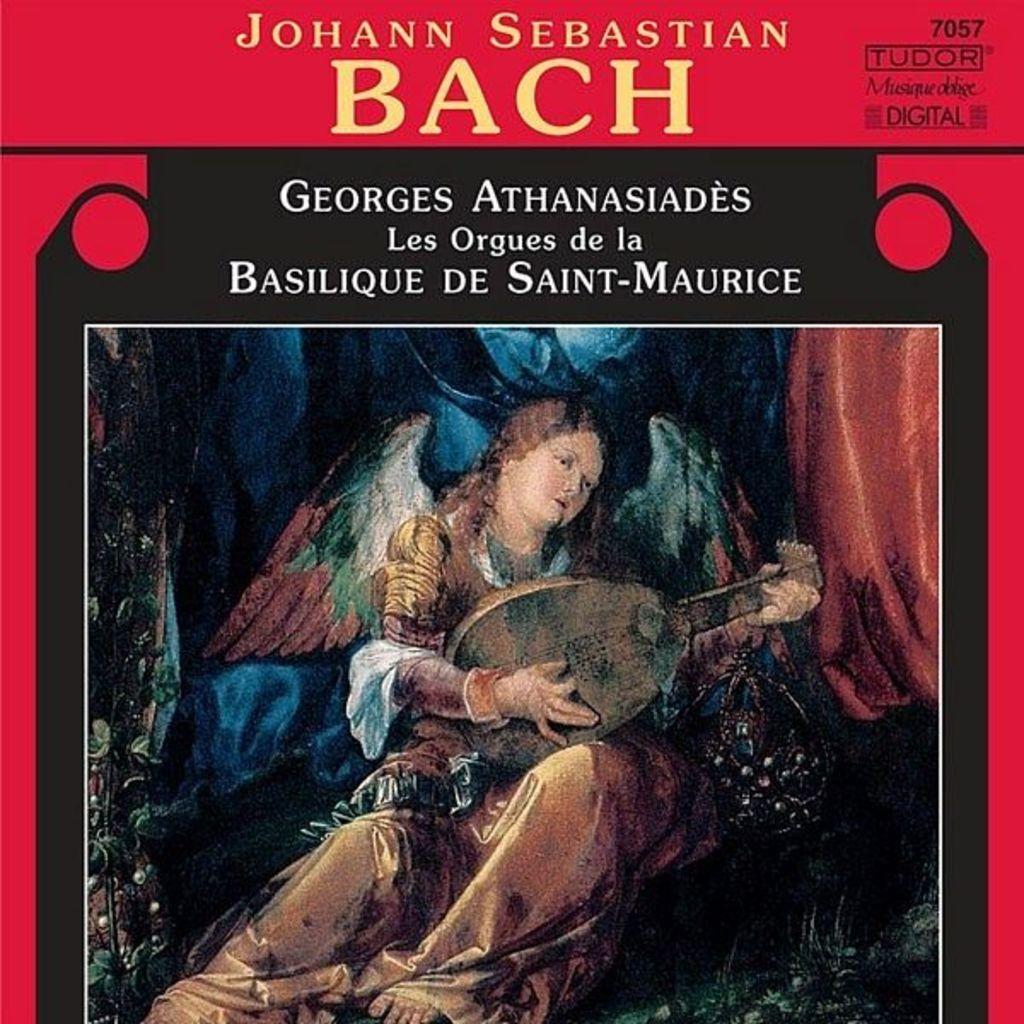In one or two sentences, can you explain what this image depicts? In this image, we can depiction of a person playing musical instrument. There is a text at the top of the image. 